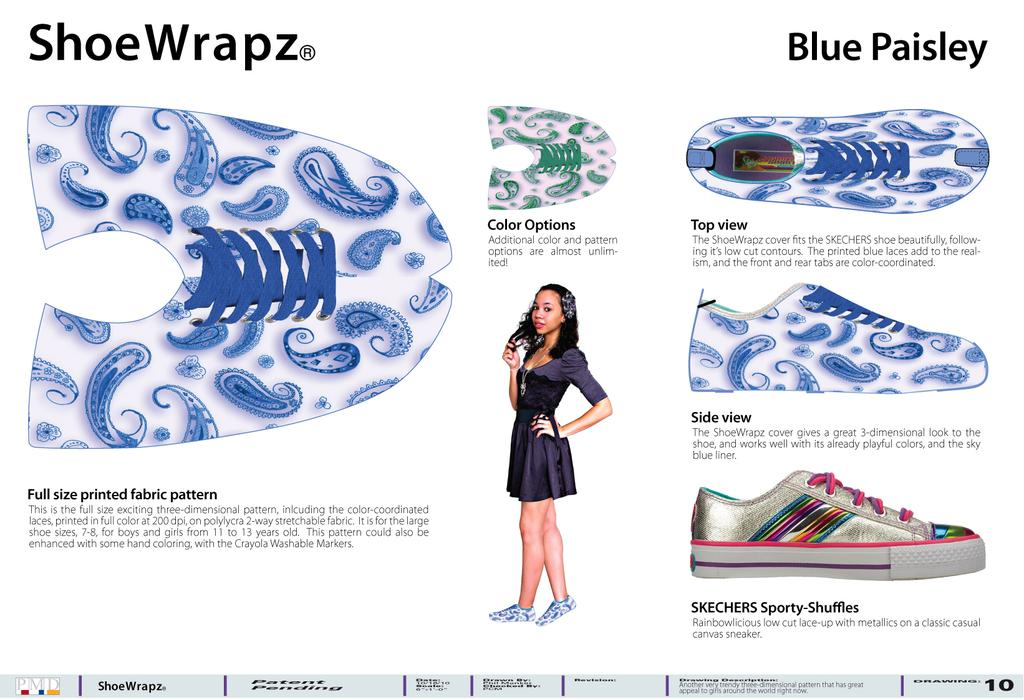What is featured on the poster in the image? The poster contains shoes and a woman wearing a black dress. What else can be seen on the poster besides the shoes and woman? There is writing on the poster. What type of unit is shown next to the woman on the poster? There is no unit present on the poster; it only features shoes, a woman wearing a black dress, and writing. 